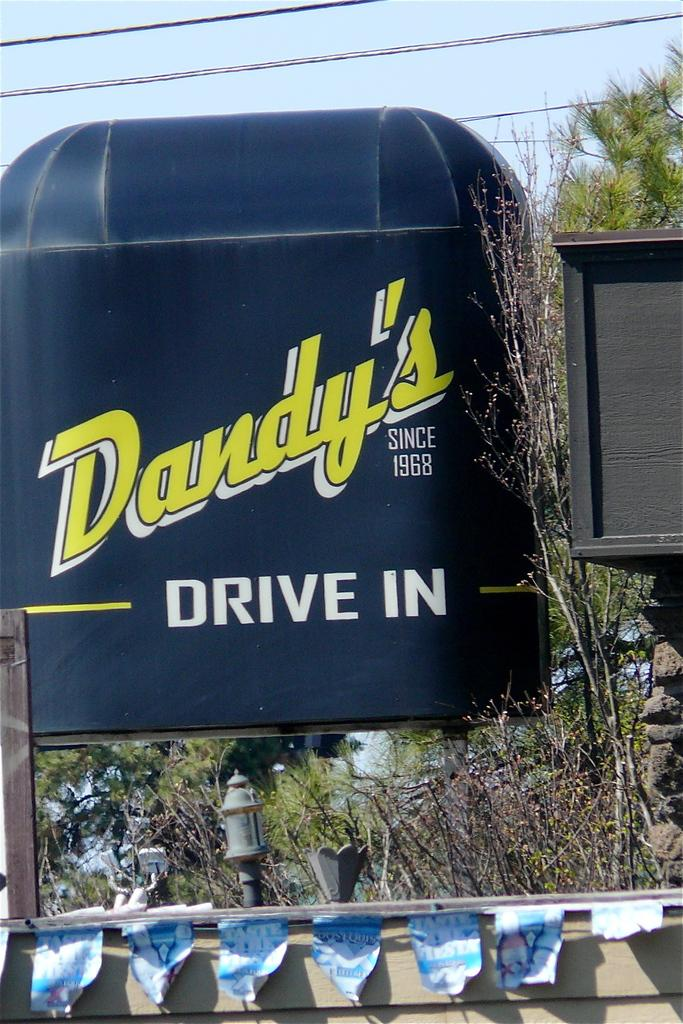What is the color of the object in the image? The object in the image is black. What is written on the black object? There is writing on the black object. What type of vegetation is present in the image? There are plants in the image. What else can be seen in the image besides the black object and plants? There are wires in the image. What can be seen in the background of the image? The sky is visible in the background of the image. Where is the nest located in the image? There is no nest present in the image. What does the black object need in order to function properly? The provided facts do not indicate any specific needs for the black object to function properly. 